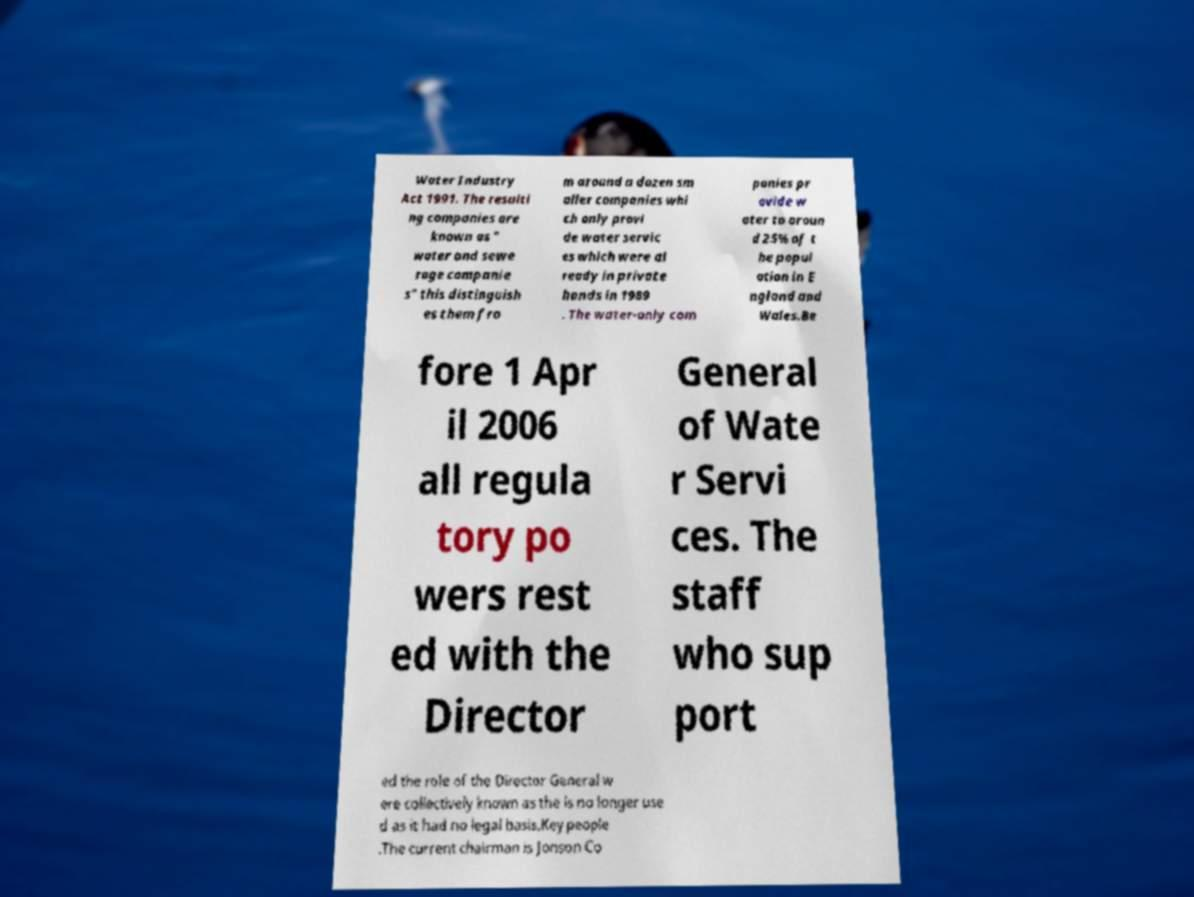Could you assist in decoding the text presented in this image and type it out clearly? Water Industry Act 1991. The resulti ng companies are known as " water and sewe rage companie s" this distinguish es them fro m around a dozen sm aller companies whi ch only provi de water servic es which were al ready in private hands in 1989 . The water-only com panies pr ovide w ater to aroun d 25% of t he popul ation in E ngland and Wales.Be fore 1 Apr il 2006 all regula tory po wers rest ed with the Director General of Wate r Servi ces. The staff who sup port ed the role of the Director General w ere collectively known as the is no longer use d as it had no legal basis.Key people .The current chairman is Jonson Co 